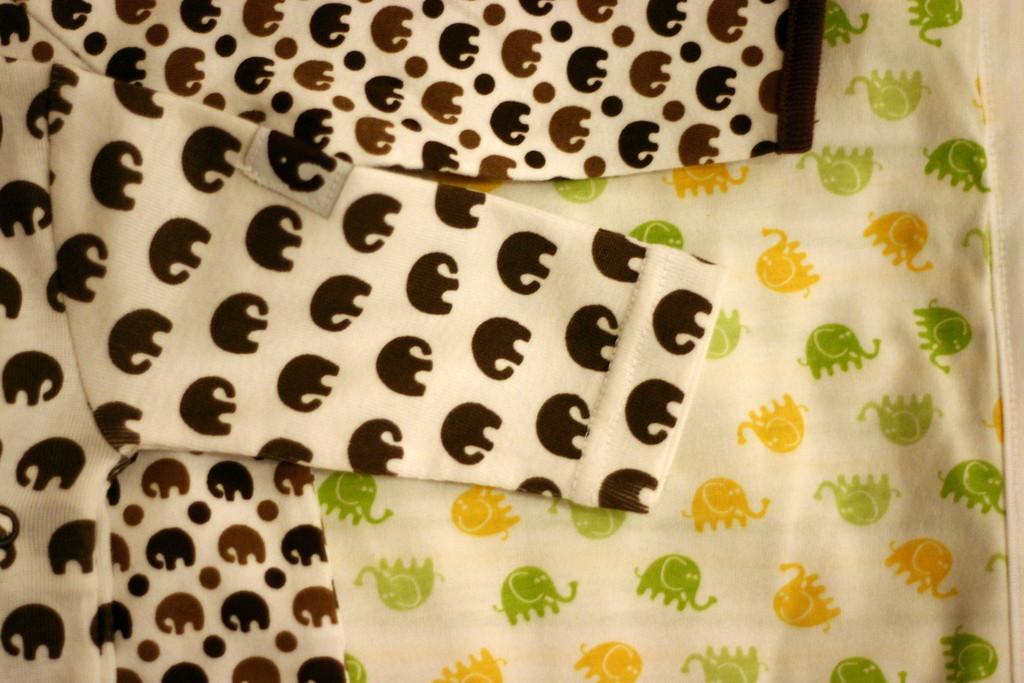What type of items can be seen in the image? There are clothes in the image. What is unique about these clothes? The clothes have paintings on them. What type of wood can be seen in the image? There is no wood present in the image; it features clothes with paintings on them. What tin object can be seen in the image? There is no tin object present in the image. 